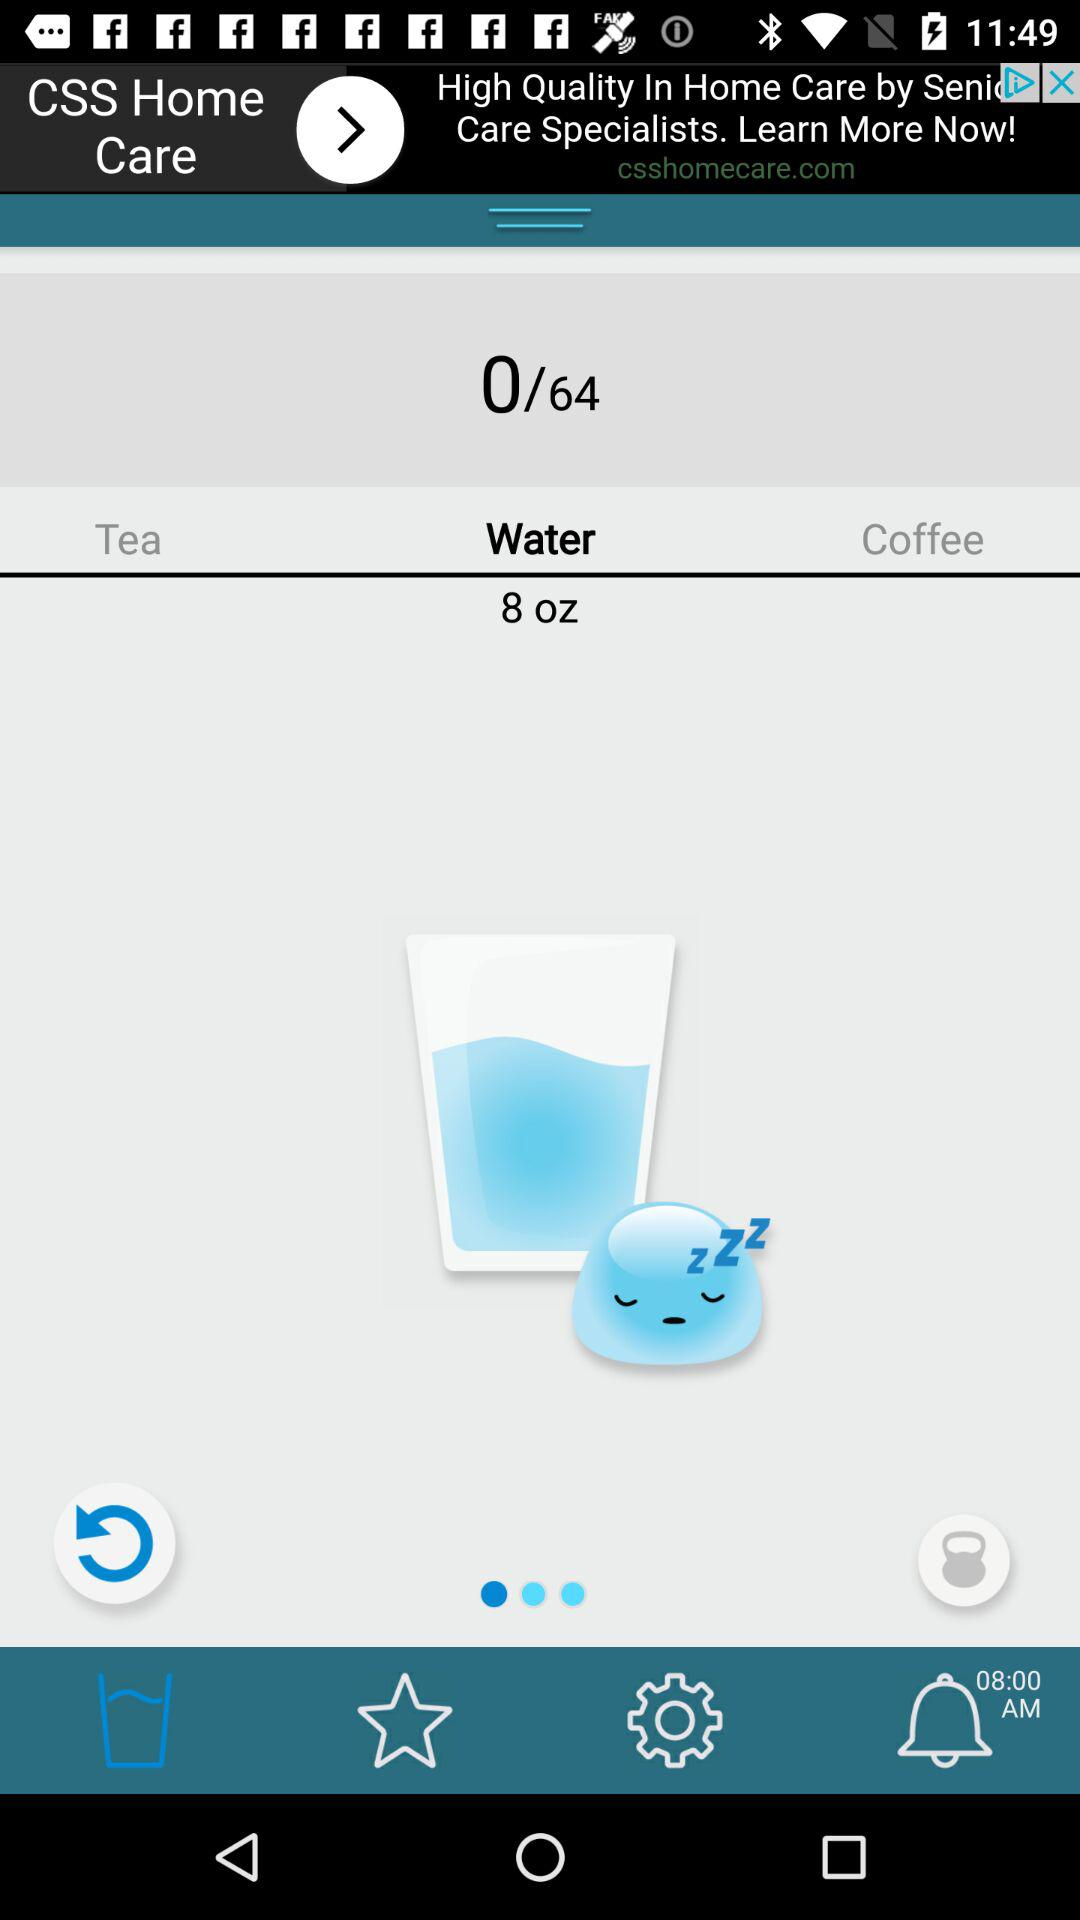How much coffee has been consumed?
When the provided information is insufficient, respond with <no answer>. <no answer> 